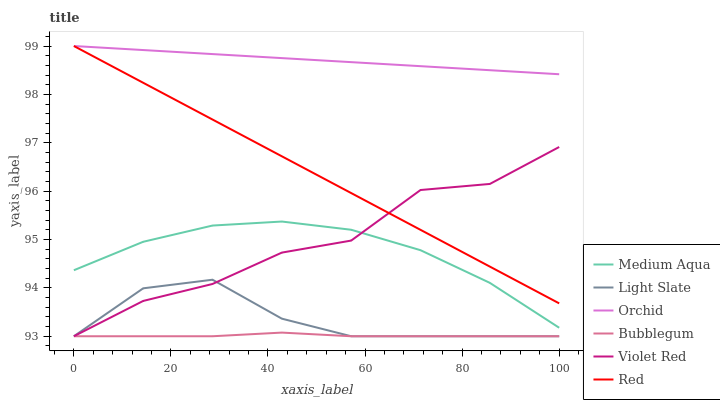Does Bubblegum have the minimum area under the curve?
Answer yes or no. Yes. Does Orchid have the maximum area under the curve?
Answer yes or no. Yes. Does Light Slate have the minimum area under the curve?
Answer yes or no. No. Does Light Slate have the maximum area under the curve?
Answer yes or no. No. Is Orchid the smoothest?
Answer yes or no. Yes. Is Violet Red the roughest?
Answer yes or no. Yes. Is Light Slate the smoothest?
Answer yes or no. No. Is Light Slate the roughest?
Answer yes or no. No. Does Violet Red have the lowest value?
Answer yes or no. Yes. Does Medium Aqua have the lowest value?
Answer yes or no. No. Does Orchid have the highest value?
Answer yes or no. Yes. Does Light Slate have the highest value?
Answer yes or no. No. Is Bubblegum less than Red?
Answer yes or no. Yes. Is Red greater than Light Slate?
Answer yes or no. Yes. Does Violet Red intersect Medium Aqua?
Answer yes or no. Yes. Is Violet Red less than Medium Aqua?
Answer yes or no. No. Is Violet Red greater than Medium Aqua?
Answer yes or no. No. Does Bubblegum intersect Red?
Answer yes or no. No. 